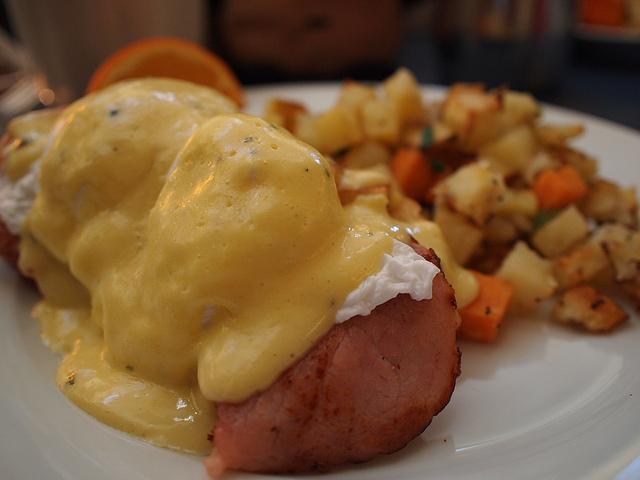Is that potato?
Short answer required. Yes. What kind of meat is here?
Give a very brief answer. Ham. What type of fruit is shown?
Give a very brief answer. Orange. Is there more than one food group on the plate?
Quick response, please. Yes. Is this dish breakfast, lunch or dinner?
Write a very short answer. Breakfast. 